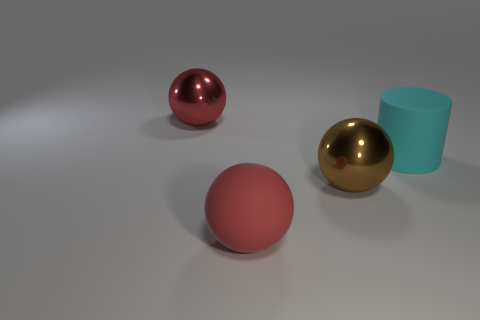What color is the rubber ball that is the same size as the cyan matte thing?
Keep it short and to the point. Red. Are there the same number of cylinders that are in front of the cyan object and cyan things?
Offer a very short reply. No. The big matte object that is in front of the metal ball right of the big red metallic object is what color?
Keep it short and to the point. Red. What size is the cyan rubber cylinder that is in front of the metallic object that is behind the cyan matte thing?
Keep it short and to the point. Large. What is the size of the other sphere that is the same color as the big rubber ball?
Your response must be concise. Large. What number of other objects are there of the same size as the matte cylinder?
Make the answer very short. 3. The shiny ball that is in front of the metal thing behind the metal thing in front of the big cyan object is what color?
Provide a short and direct response. Brown. How many other things are the same shape as the big red rubber thing?
Your answer should be very brief. 2. What shape is the matte object to the left of the cyan matte object?
Give a very brief answer. Sphere. There is a shiny object that is on the left side of the large brown metallic thing; is there a big red ball that is behind it?
Give a very brief answer. No. 